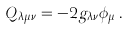<formula> <loc_0><loc_0><loc_500><loc_500>Q _ { \lambda \mu \nu } = - 2 g _ { \lambda \nu } \phi _ { \mu } \, .</formula> 